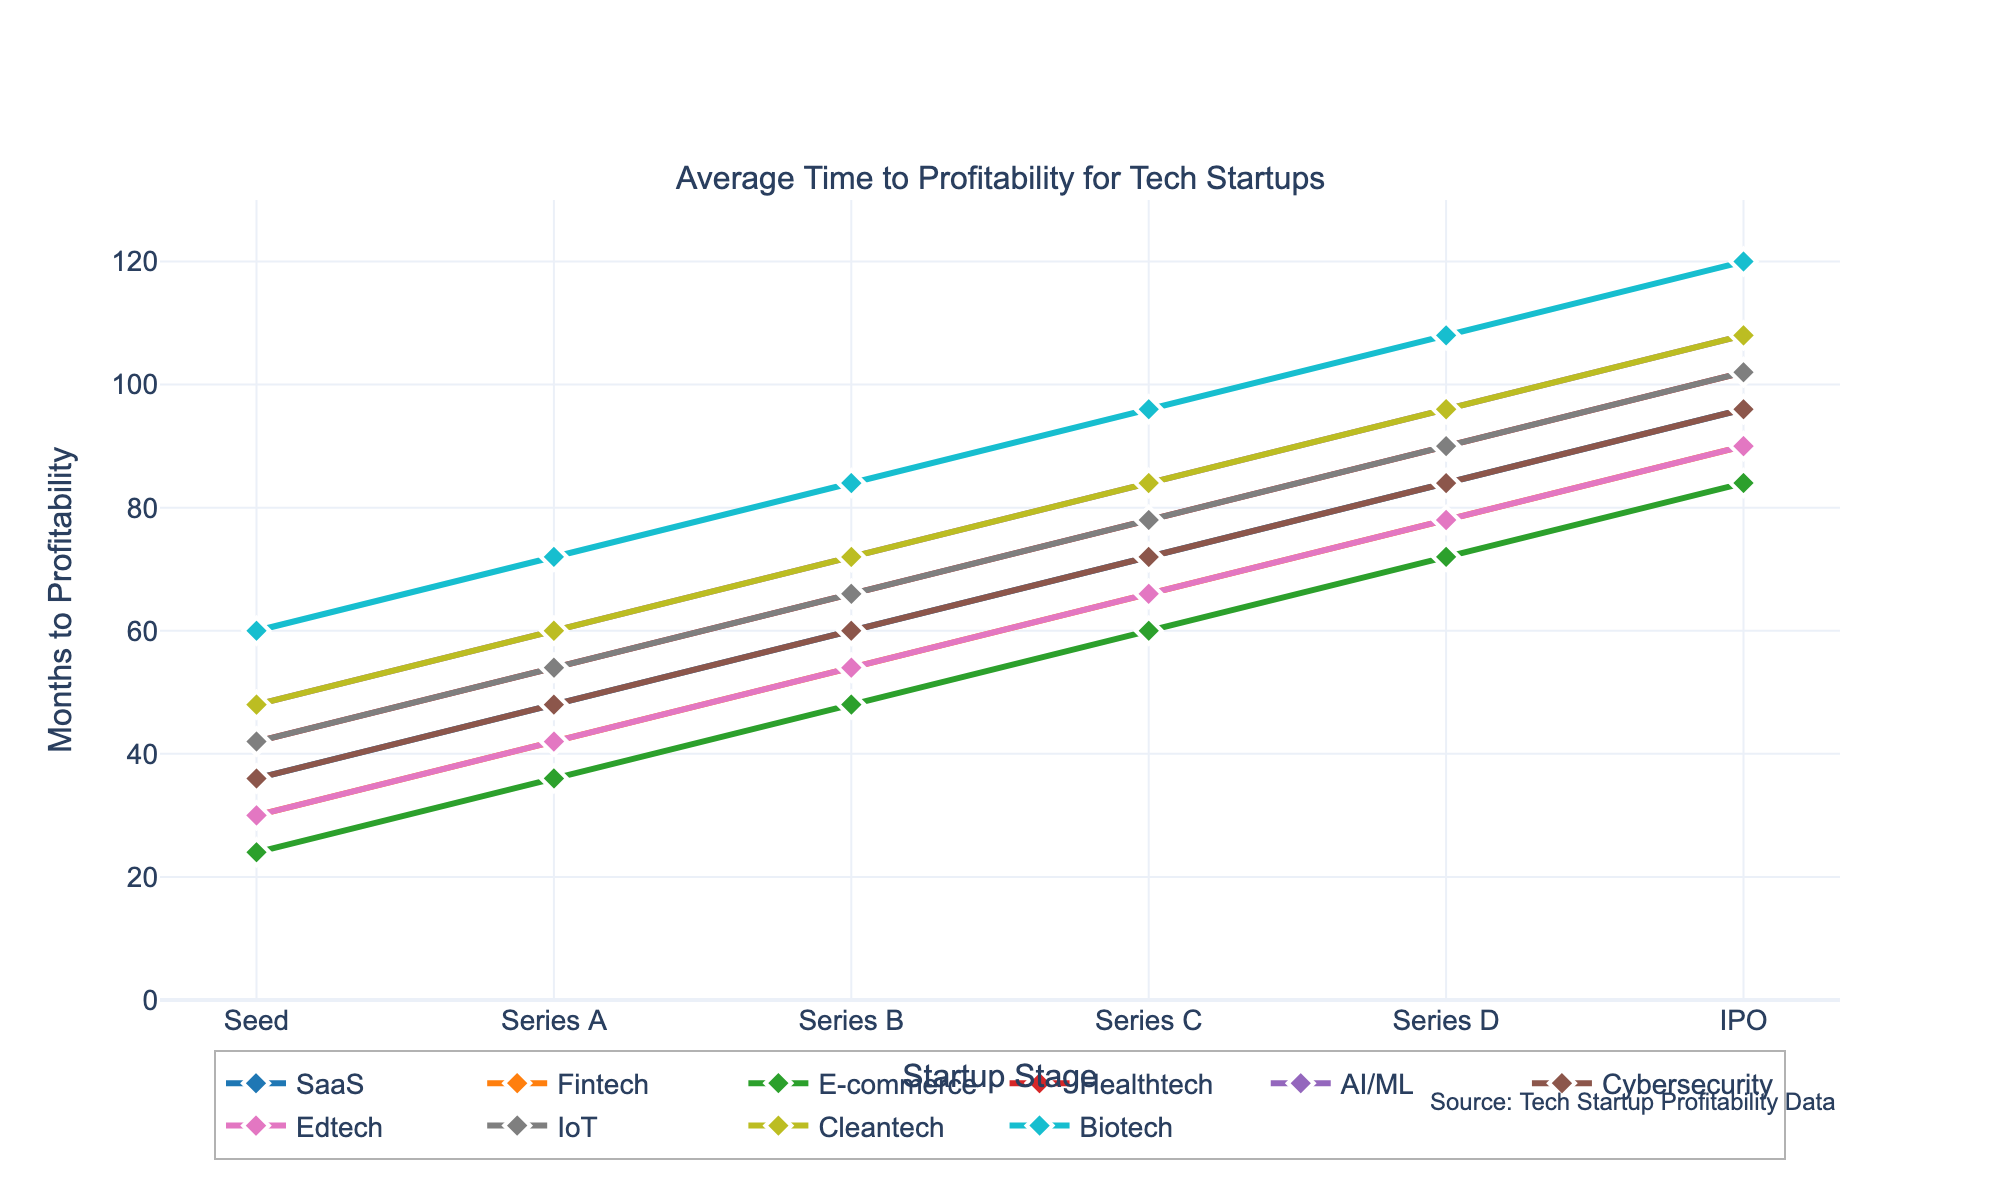What is the average time to profitability for the SaaS industry from Seed stage to IPO? To determine the average time to profitability for the SaaS industry, sum the months from Seed to IPO and then divide by the number of stages. The values are 36, 48, 60, 72, 84, and 96. The total is 36 + 48 + 60 + 72 + 84 + 96 = 396. There are 6 stages, so the average is 396 / 6 = 66 months.
Answer: 66 Which industry takes the longest time to reach profitability at the IPO stage? Identify the industry with the highest value at the IPO stage. The values are: SaaS (96), Fintech (90), E-commerce (84), Healthtech (102), AI/ML (108), Cybersecurity (96), Edtech (90), IoT (102), Cleantech (108), Biotech (120). Biotech has the highest value of 120.
Answer: Biotech How much longer does it take for the AI/ML industry to reach profitability at Series B compared to the E-commerce industry? Locate the time to profitability at Series B for AI/ML (72) and E-commerce (48). Subtract the E-commerce value from the AI/ML value. 72 - 48 = 24 months.
Answer: 24 Compare the time to profitability at Series C stage between Fintech and Edtech. Which industry reaches profitability faster and by how many months? Determine the time to profitability at Series C for Fintech (66) and Edtech (66). Since both values are equal, neither industry reaches profitability faster.
Answer: 0 Which industries have the same time to profitability at the Series A stage, and what is that time? Identify the values at Series A across industries. The values are: SaaS (48), Fintech (42), E-commerce (36), Healthtech (54), AI/ML (60), Cybersecurity (48), Edtech (42), IoT (54), Cleantech (60), Biotech (72). SaaS and Cybersecurity share the same time of 48 months; Fintech and Edtech share the same time of 42 months; Healthtech and IoT share the same time of 54 months.
Answer: SaaS and Cybersecurity: 48, Fintech and Edtech: 42, Healthtech and IoT: 54 